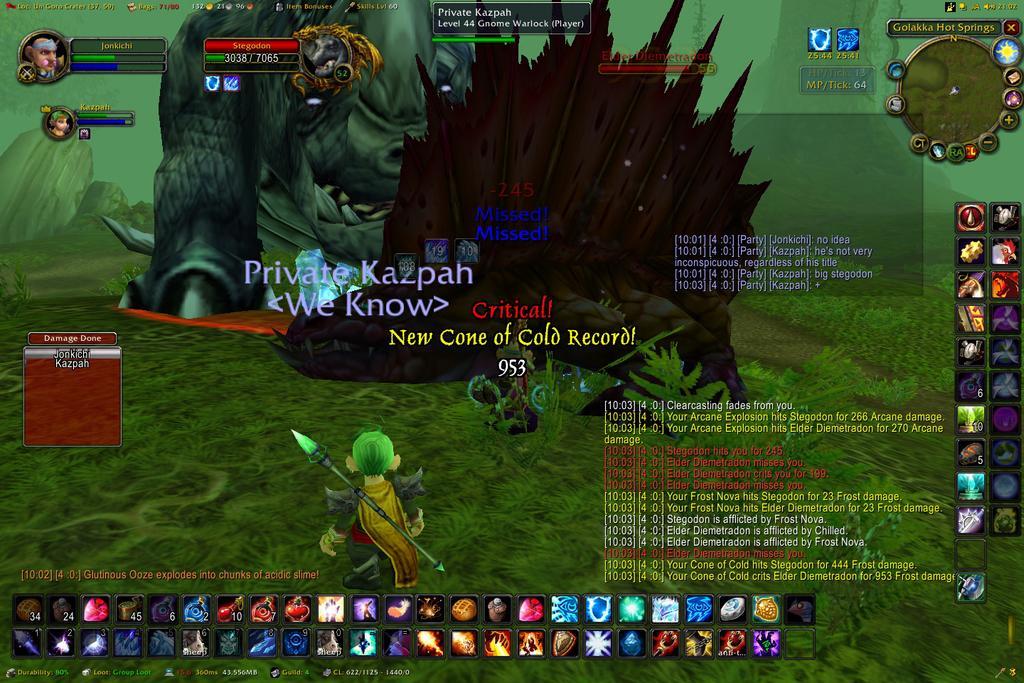How would you summarize this image in a sentence or two? This is a screen having cartoon images, texts and icons. And the background is green in color. 